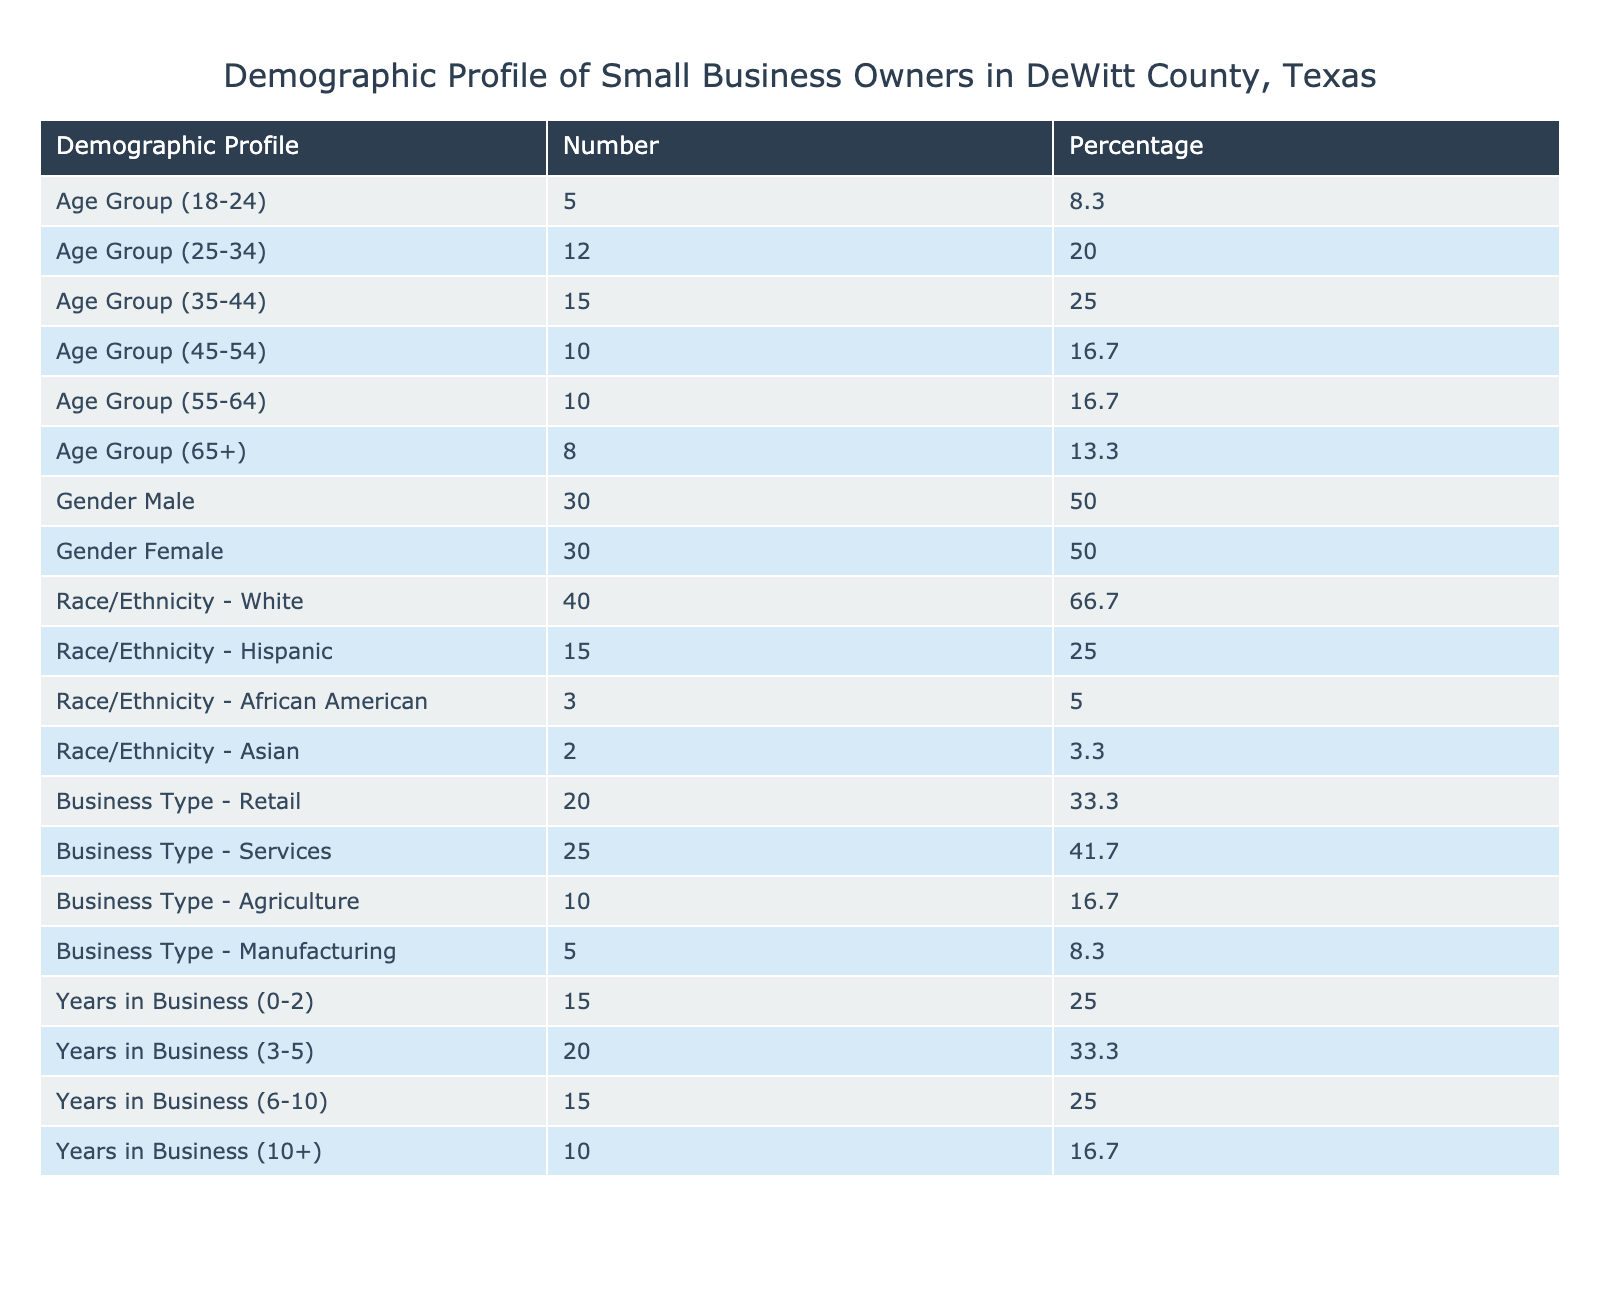What is the percentage of small business owners aged 35-44? According to the table, the number of small business owners in the age group 35-44 is 15. The percentage of this group is given directly in the table as 25.0%.
Answer: 25.0% How many small business owners are in the female category? The table shows that there are 30 female small business owners. This value can be retrieved directly from the data provided.
Answer: 30 What is the combined percentage of business owners aged 55 and older? The percentages for the age groups 55-64 (16.7%) and 65+ (13.3%) need to be added together: 16.7% + 13.3% = 30.0%.
Answer: 30.0% Are there more male or female small business owners? The table indicates that there are 30 male and 30 female small business owners. Since both numbers are equal, the answer is no, there aren’t more of either gender.
Answer: No What percentage of small business owners belong to the Hispanic category? The table shows that the number of Hispanic small business owners is 15, which represents 25.0% of the total. This can be directly found in the demographics section of the table.
Answer: 25.0% What is the total number of small business owners in the Agriculture sector? The table lists the number of small business owners in the Agriculture sector as 10. This value is found directly in the business type classification in the table.
Answer: 10 What is the average number of years in business for those who have been operating for 3 to 5 years? The table shows that 20 out of the total small business owners have been in business for 3-5 years. While it does not provide the average directly, we can simply note the number in this category. Since there is no further breakdown, we cannot calculate a mathematical average using just this information. Therefore, the answer is based on retrieval.
Answer: 20 How many more small business owners are in the Services category compared to Manufacturing? The number of small business owners in the Services category is 25 and in Manufacturing, it is 5. The difference is 25 - 5 = 20.
Answer: 20 What is the most common race/ethnicity among small business owners in DeWitt County? The table indicates that 40 small business owners identify as White, which is the largest number compared to other races/ethnicities listed (Hispanic 15, African American 3, Asian 2). This shows that White is the most common race/ethnicity.
Answer: White 